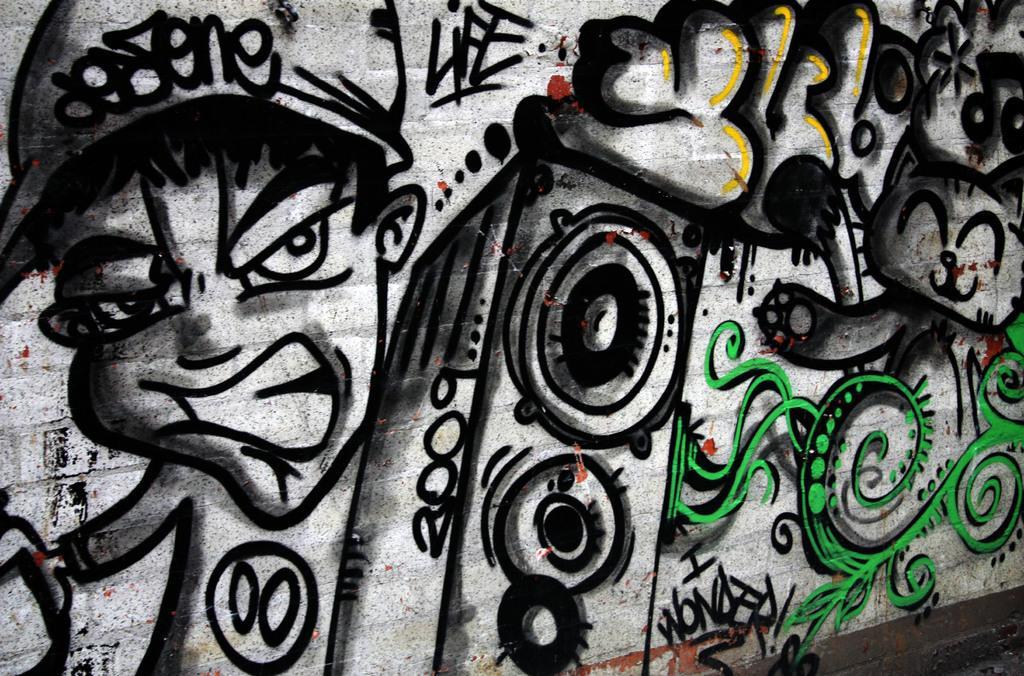Could you give a brief overview of what you see in this image? Here there is a drawing of a boy on the wall. 